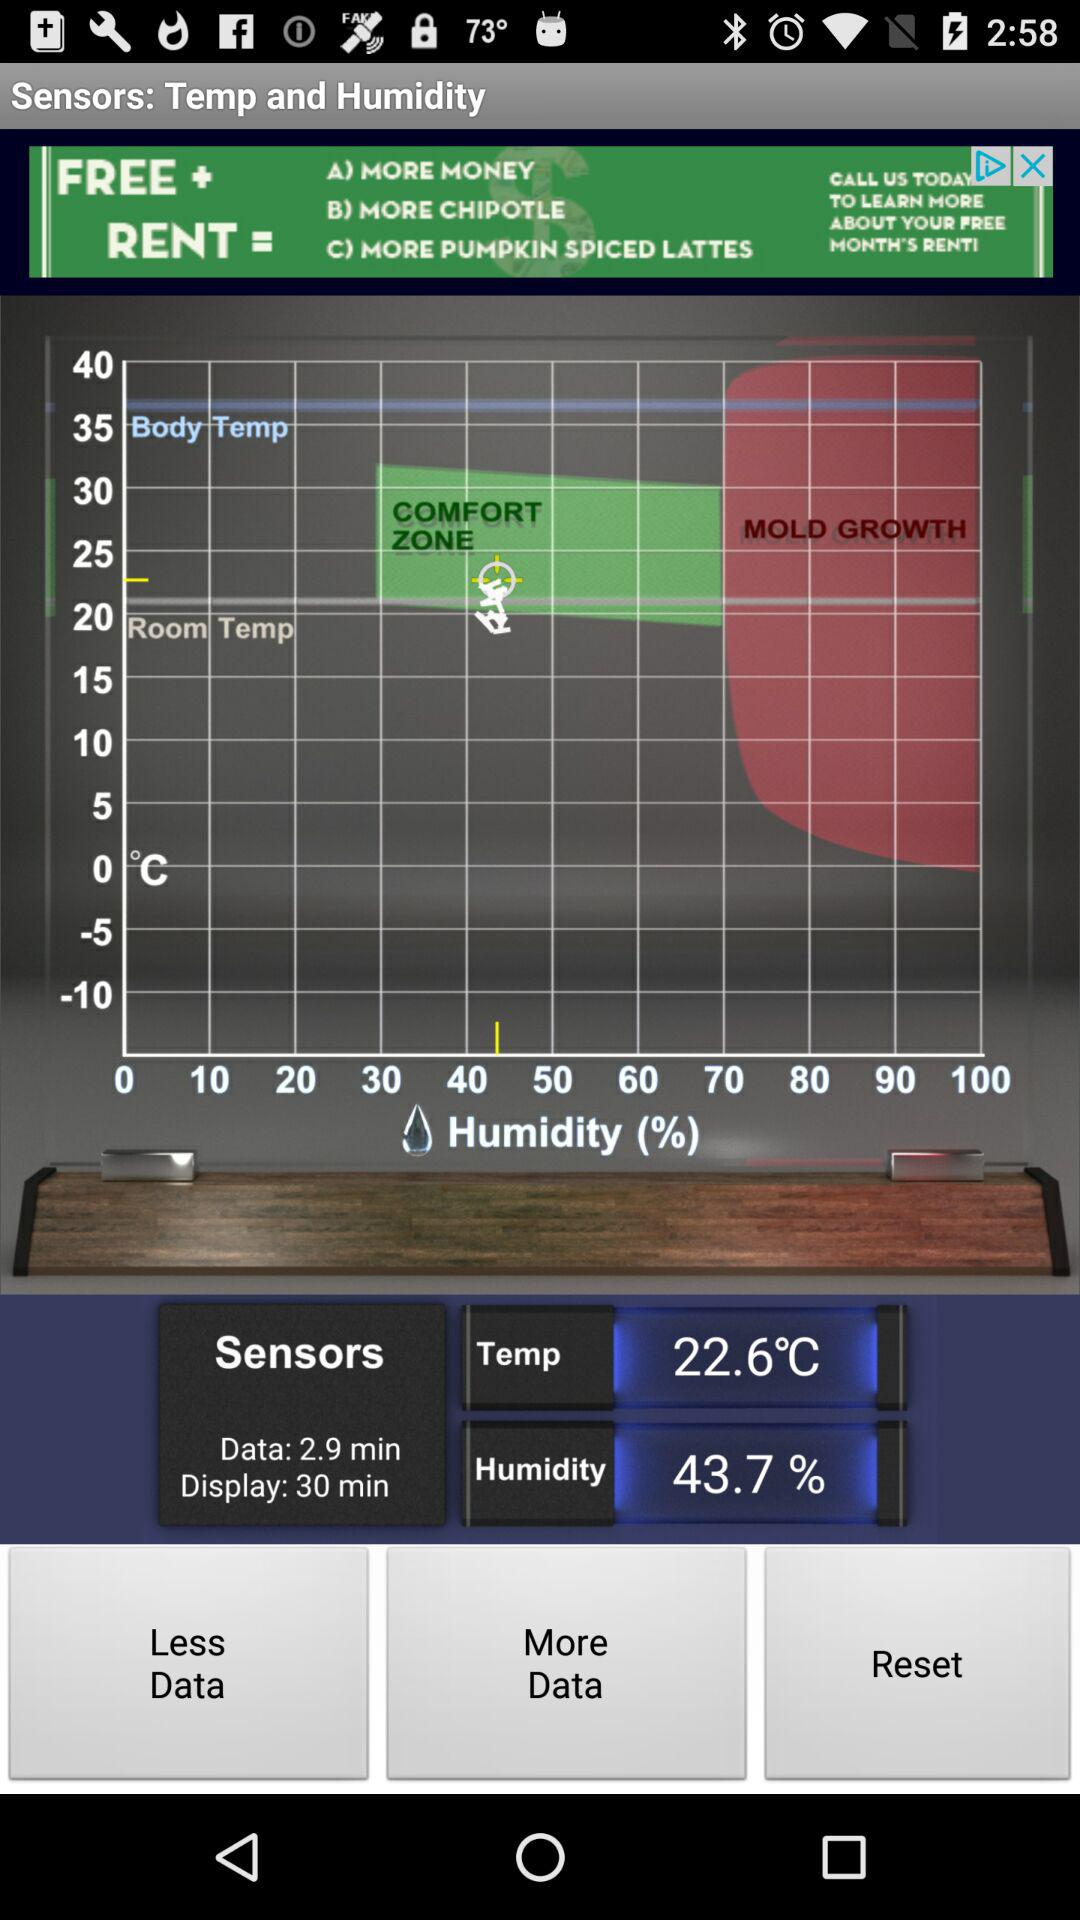What is the humidity? The humidity is 43.7 %. 